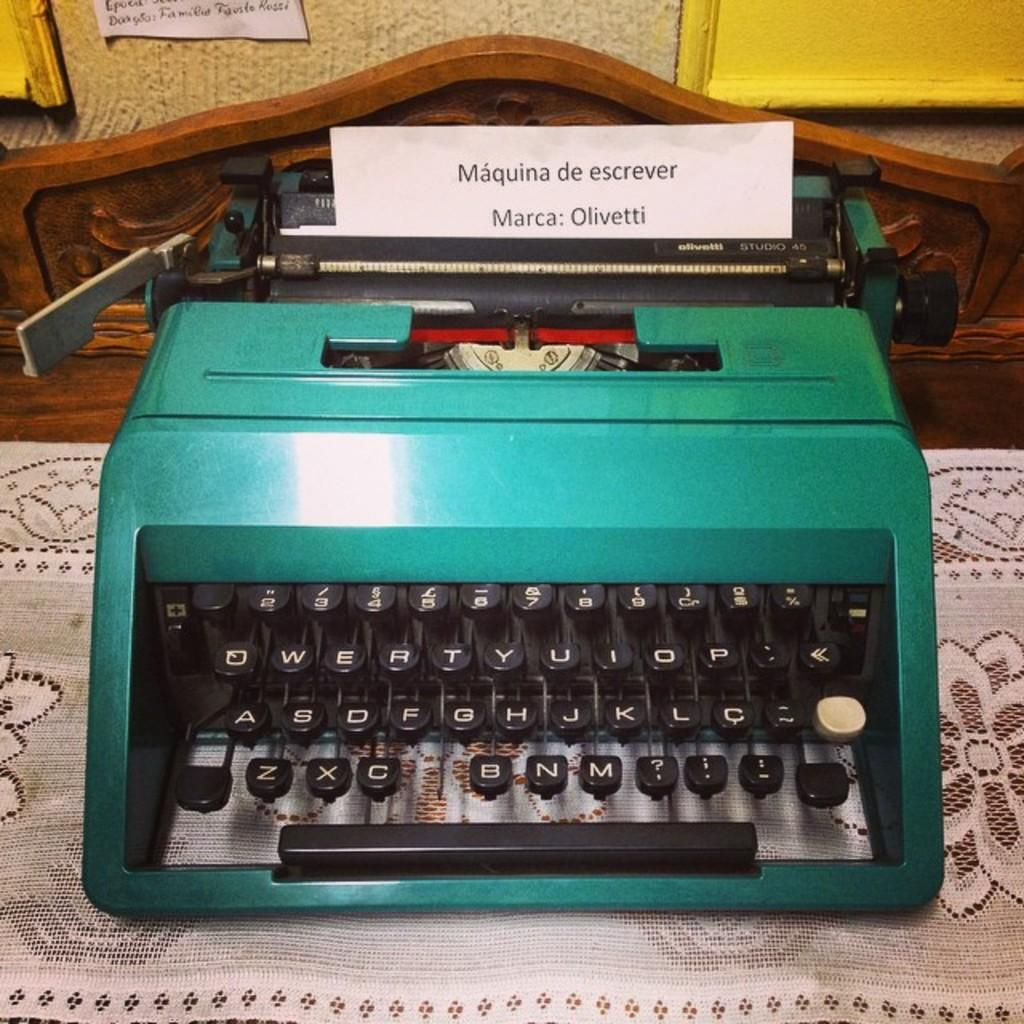<image>
Present a compact description of the photo's key features. A green manual typewriter with a label  in the wheel that says machina de escrever. 